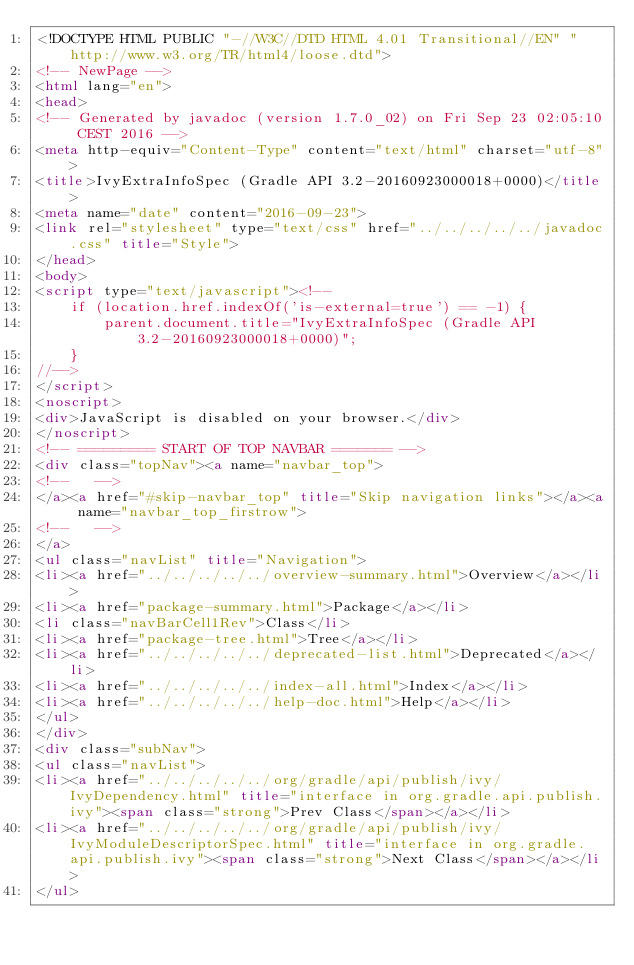Convert code to text. <code><loc_0><loc_0><loc_500><loc_500><_HTML_><!DOCTYPE HTML PUBLIC "-//W3C//DTD HTML 4.01 Transitional//EN" "http://www.w3.org/TR/html4/loose.dtd">
<!-- NewPage -->
<html lang="en">
<head>
<!-- Generated by javadoc (version 1.7.0_02) on Fri Sep 23 02:05:10 CEST 2016 -->
<meta http-equiv="Content-Type" content="text/html" charset="utf-8">
<title>IvyExtraInfoSpec (Gradle API 3.2-20160923000018+0000)</title>
<meta name="date" content="2016-09-23">
<link rel="stylesheet" type="text/css" href="../../../../../javadoc.css" title="Style">
</head>
<body>
<script type="text/javascript"><!--
    if (location.href.indexOf('is-external=true') == -1) {
        parent.document.title="IvyExtraInfoSpec (Gradle API 3.2-20160923000018+0000)";
    }
//-->
</script>
<noscript>
<div>JavaScript is disabled on your browser.</div>
</noscript>
<!-- ========= START OF TOP NAVBAR ======= -->
<div class="topNav"><a name="navbar_top">
<!--   -->
</a><a href="#skip-navbar_top" title="Skip navigation links"></a><a name="navbar_top_firstrow">
<!--   -->
</a>
<ul class="navList" title="Navigation">
<li><a href="../../../../../overview-summary.html">Overview</a></li>
<li><a href="package-summary.html">Package</a></li>
<li class="navBarCell1Rev">Class</li>
<li><a href="package-tree.html">Tree</a></li>
<li><a href="../../../../../deprecated-list.html">Deprecated</a></li>
<li><a href="../../../../../index-all.html">Index</a></li>
<li><a href="../../../../../help-doc.html">Help</a></li>
</ul>
</div>
<div class="subNav">
<ul class="navList">
<li><a href="../../../../../org/gradle/api/publish/ivy/IvyDependency.html" title="interface in org.gradle.api.publish.ivy"><span class="strong">Prev Class</span></a></li>
<li><a href="../../../../../org/gradle/api/publish/ivy/IvyModuleDescriptorSpec.html" title="interface in org.gradle.api.publish.ivy"><span class="strong">Next Class</span></a></li>
</ul></code> 